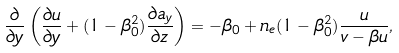Convert formula to latex. <formula><loc_0><loc_0><loc_500><loc_500>\frac { \partial } { \partial { y } } \left ( \frac { \partial { u } } { \partial { y } } + ( 1 - \beta ^ { 2 } _ { 0 } ) \frac { \partial { a _ { y } } } { \partial { z } } \right ) = - \beta _ { 0 } + n _ { e } ( 1 - \beta _ { 0 } ^ { 2 } ) \frac { u } { v - \beta u } ,</formula> 